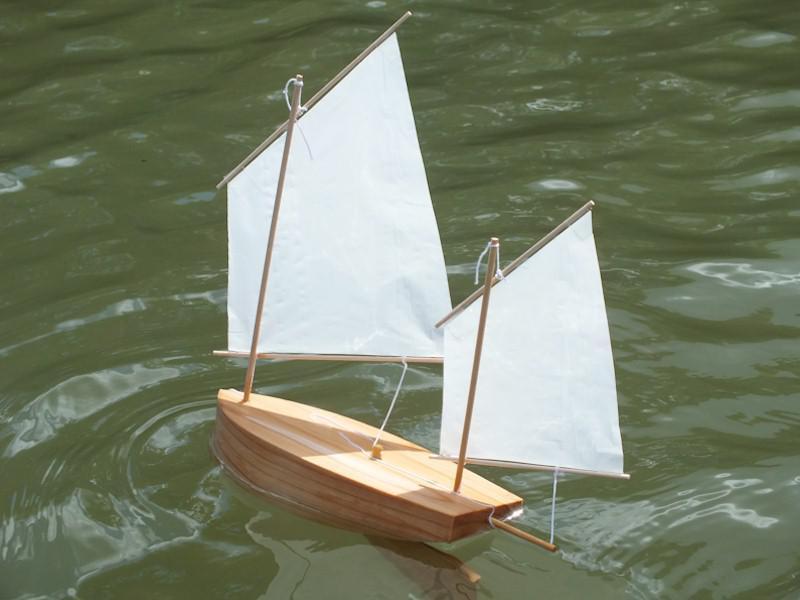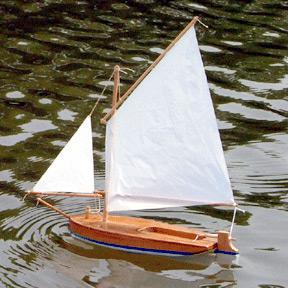The first image is the image on the left, the second image is the image on the right. Evaluate the accuracy of this statement regarding the images: "Both of the boats are in the water.". Is it true? Answer yes or no. Yes. The first image is the image on the left, the second image is the image on the right. Analyze the images presented: Is the assertion "Each image shows a boat on the water, and at least one of the boats looks like a wooden model instead of a full-size boat." valid? Answer yes or no. Yes. 